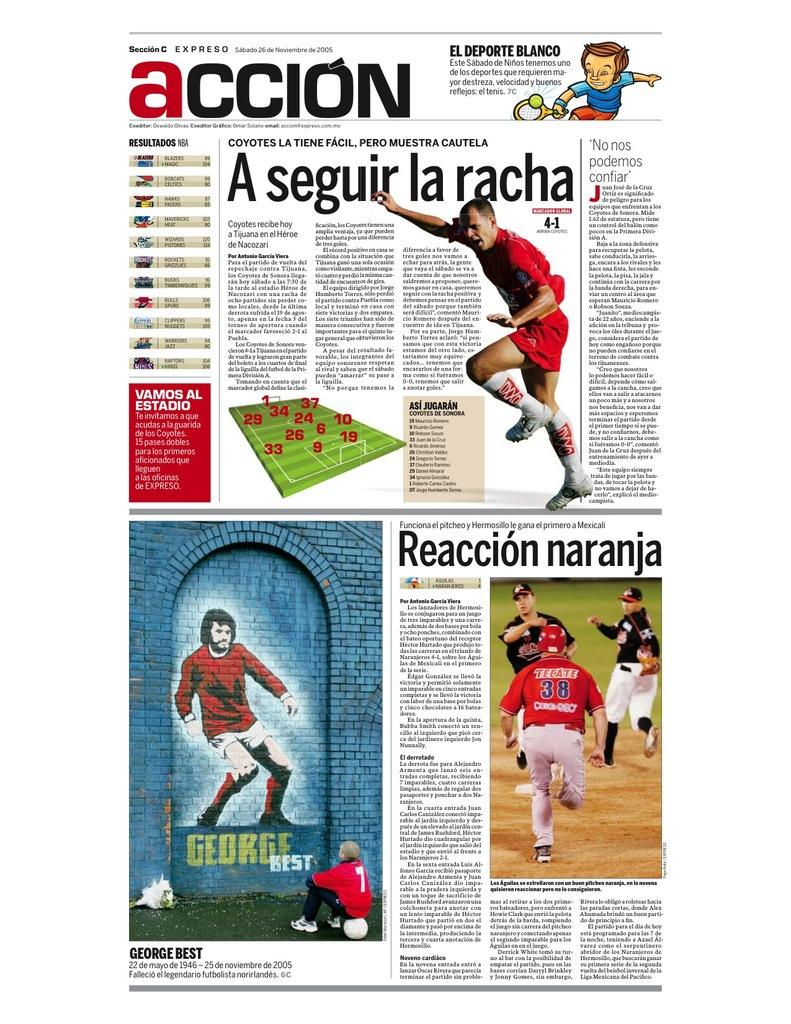<image>
Present a compact description of the photo's key features. the word accion is on the white paper 